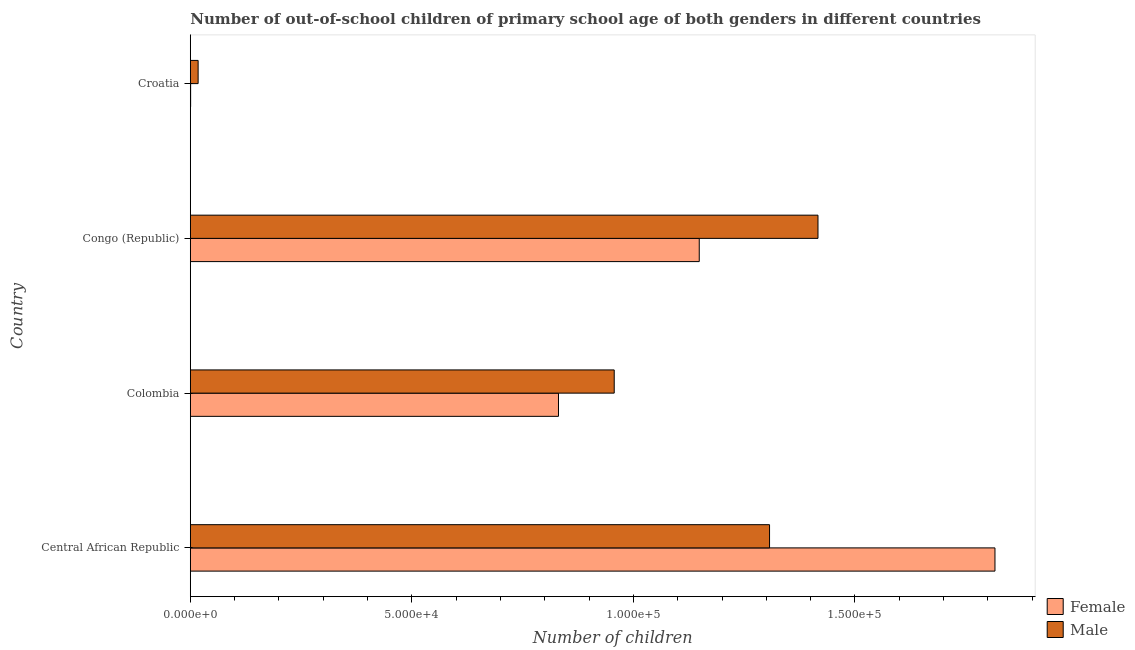How many groups of bars are there?
Offer a very short reply. 4. How many bars are there on the 2nd tick from the top?
Keep it short and to the point. 2. How many bars are there on the 2nd tick from the bottom?
Provide a succinct answer. 2. What is the label of the 3rd group of bars from the top?
Make the answer very short. Colombia. In how many cases, is the number of bars for a given country not equal to the number of legend labels?
Your response must be concise. 0. What is the number of female out-of-school students in Colombia?
Ensure brevity in your answer.  8.31e+04. Across all countries, what is the maximum number of female out-of-school students?
Provide a short and direct response. 1.82e+05. Across all countries, what is the minimum number of female out-of-school students?
Your answer should be compact. 76. In which country was the number of male out-of-school students maximum?
Offer a terse response. Congo (Republic). In which country was the number of female out-of-school students minimum?
Offer a very short reply. Croatia. What is the total number of female out-of-school students in the graph?
Your answer should be compact. 3.80e+05. What is the difference between the number of male out-of-school students in Congo (Republic) and that in Croatia?
Offer a terse response. 1.40e+05. What is the difference between the number of female out-of-school students in Colombia and the number of male out-of-school students in Central African Republic?
Your answer should be very brief. -4.76e+04. What is the average number of male out-of-school students per country?
Your answer should be compact. 9.25e+04. What is the difference between the number of female out-of-school students and number of male out-of-school students in Congo (Republic)?
Your answer should be compact. -2.68e+04. What is the ratio of the number of female out-of-school students in Central African Republic to that in Colombia?
Offer a terse response. 2.19. What is the difference between the highest and the second highest number of male out-of-school students?
Offer a terse response. 1.09e+04. What is the difference between the highest and the lowest number of male out-of-school students?
Your answer should be compact. 1.40e+05. How many countries are there in the graph?
Your answer should be compact. 4. Does the graph contain grids?
Your response must be concise. No. Where does the legend appear in the graph?
Keep it short and to the point. Bottom right. How many legend labels are there?
Ensure brevity in your answer.  2. How are the legend labels stacked?
Provide a short and direct response. Vertical. What is the title of the graph?
Your answer should be very brief. Number of out-of-school children of primary school age of both genders in different countries. Does "Subsidies" appear as one of the legend labels in the graph?
Give a very brief answer. No. What is the label or title of the X-axis?
Your answer should be very brief. Number of children. What is the Number of children of Female in Central African Republic?
Provide a short and direct response. 1.82e+05. What is the Number of children in Male in Central African Republic?
Your answer should be compact. 1.31e+05. What is the Number of children of Female in Colombia?
Your response must be concise. 8.31e+04. What is the Number of children in Male in Colombia?
Offer a terse response. 9.57e+04. What is the Number of children of Female in Congo (Republic)?
Your response must be concise. 1.15e+05. What is the Number of children in Male in Congo (Republic)?
Your answer should be compact. 1.42e+05. What is the Number of children in Male in Croatia?
Provide a short and direct response. 1768. Across all countries, what is the maximum Number of children in Female?
Provide a short and direct response. 1.82e+05. Across all countries, what is the maximum Number of children in Male?
Offer a very short reply. 1.42e+05. Across all countries, what is the minimum Number of children in Female?
Provide a short and direct response. 76. Across all countries, what is the minimum Number of children of Male?
Make the answer very short. 1768. What is the total Number of children of Female in the graph?
Your answer should be compact. 3.80e+05. What is the total Number of children in Male in the graph?
Offer a very short reply. 3.70e+05. What is the difference between the Number of children in Female in Central African Republic and that in Colombia?
Offer a very short reply. 9.85e+04. What is the difference between the Number of children in Male in Central African Republic and that in Colombia?
Your answer should be very brief. 3.51e+04. What is the difference between the Number of children in Female in Central African Republic and that in Congo (Republic)?
Provide a short and direct response. 6.67e+04. What is the difference between the Number of children in Male in Central African Republic and that in Congo (Republic)?
Give a very brief answer. -1.09e+04. What is the difference between the Number of children of Female in Central African Republic and that in Croatia?
Provide a succinct answer. 1.82e+05. What is the difference between the Number of children of Male in Central African Republic and that in Croatia?
Make the answer very short. 1.29e+05. What is the difference between the Number of children of Female in Colombia and that in Congo (Republic)?
Make the answer very short. -3.18e+04. What is the difference between the Number of children in Male in Colombia and that in Congo (Republic)?
Make the answer very short. -4.60e+04. What is the difference between the Number of children of Female in Colombia and that in Croatia?
Give a very brief answer. 8.30e+04. What is the difference between the Number of children of Male in Colombia and that in Croatia?
Provide a short and direct response. 9.39e+04. What is the difference between the Number of children of Female in Congo (Republic) and that in Croatia?
Give a very brief answer. 1.15e+05. What is the difference between the Number of children of Male in Congo (Republic) and that in Croatia?
Your answer should be compact. 1.40e+05. What is the difference between the Number of children of Female in Central African Republic and the Number of children of Male in Colombia?
Provide a succinct answer. 8.59e+04. What is the difference between the Number of children in Female in Central African Republic and the Number of children in Male in Congo (Republic)?
Your answer should be very brief. 3.99e+04. What is the difference between the Number of children in Female in Central African Republic and the Number of children in Male in Croatia?
Offer a terse response. 1.80e+05. What is the difference between the Number of children in Female in Colombia and the Number of children in Male in Congo (Republic)?
Offer a terse response. -5.86e+04. What is the difference between the Number of children of Female in Colombia and the Number of children of Male in Croatia?
Provide a short and direct response. 8.13e+04. What is the difference between the Number of children of Female in Congo (Republic) and the Number of children of Male in Croatia?
Ensure brevity in your answer.  1.13e+05. What is the average Number of children in Female per country?
Offer a terse response. 9.49e+04. What is the average Number of children of Male per country?
Give a very brief answer. 9.25e+04. What is the difference between the Number of children in Female and Number of children in Male in Central African Republic?
Your answer should be very brief. 5.09e+04. What is the difference between the Number of children of Female and Number of children of Male in Colombia?
Provide a succinct answer. -1.26e+04. What is the difference between the Number of children of Female and Number of children of Male in Congo (Republic)?
Provide a succinct answer. -2.68e+04. What is the difference between the Number of children in Female and Number of children in Male in Croatia?
Your answer should be compact. -1692. What is the ratio of the Number of children in Female in Central African Republic to that in Colombia?
Keep it short and to the point. 2.19. What is the ratio of the Number of children in Male in Central African Republic to that in Colombia?
Your response must be concise. 1.37. What is the ratio of the Number of children of Female in Central African Republic to that in Congo (Republic)?
Provide a short and direct response. 1.58. What is the ratio of the Number of children of Male in Central African Republic to that in Congo (Republic)?
Offer a very short reply. 0.92. What is the ratio of the Number of children of Female in Central African Republic to that in Croatia?
Give a very brief answer. 2389.45. What is the ratio of the Number of children in Male in Central African Republic to that in Croatia?
Ensure brevity in your answer.  73.94. What is the ratio of the Number of children of Female in Colombia to that in Congo (Republic)?
Offer a very short reply. 0.72. What is the ratio of the Number of children in Male in Colombia to that in Congo (Republic)?
Ensure brevity in your answer.  0.68. What is the ratio of the Number of children of Female in Colombia to that in Croatia?
Your answer should be very brief. 1093.32. What is the ratio of the Number of children in Male in Colombia to that in Croatia?
Provide a succinct answer. 54.11. What is the ratio of the Number of children in Female in Congo (Republic) to that in Croatia?
Ensure brevity in your answer.  1511.36. What is the ratio of the Number of children of Male in Congo (Republic) to that in Croatia?
Your response must be concise. 80.12. What is the difference between the highest and the second highest Number of children of Female?
Offer a terse response. 6.67e+04. What is the difference between the highest and the second highest Number of children in Male?
Make the answer very short. 1.09e+04. What is the difference between the highest and the lowest Number of children in Female?
Ensure brevity in your answer.  1.82e+05. What is the difference between the highest and the lowest Number of children in Male?
Keep it short and to the point. 1.40e+05. 